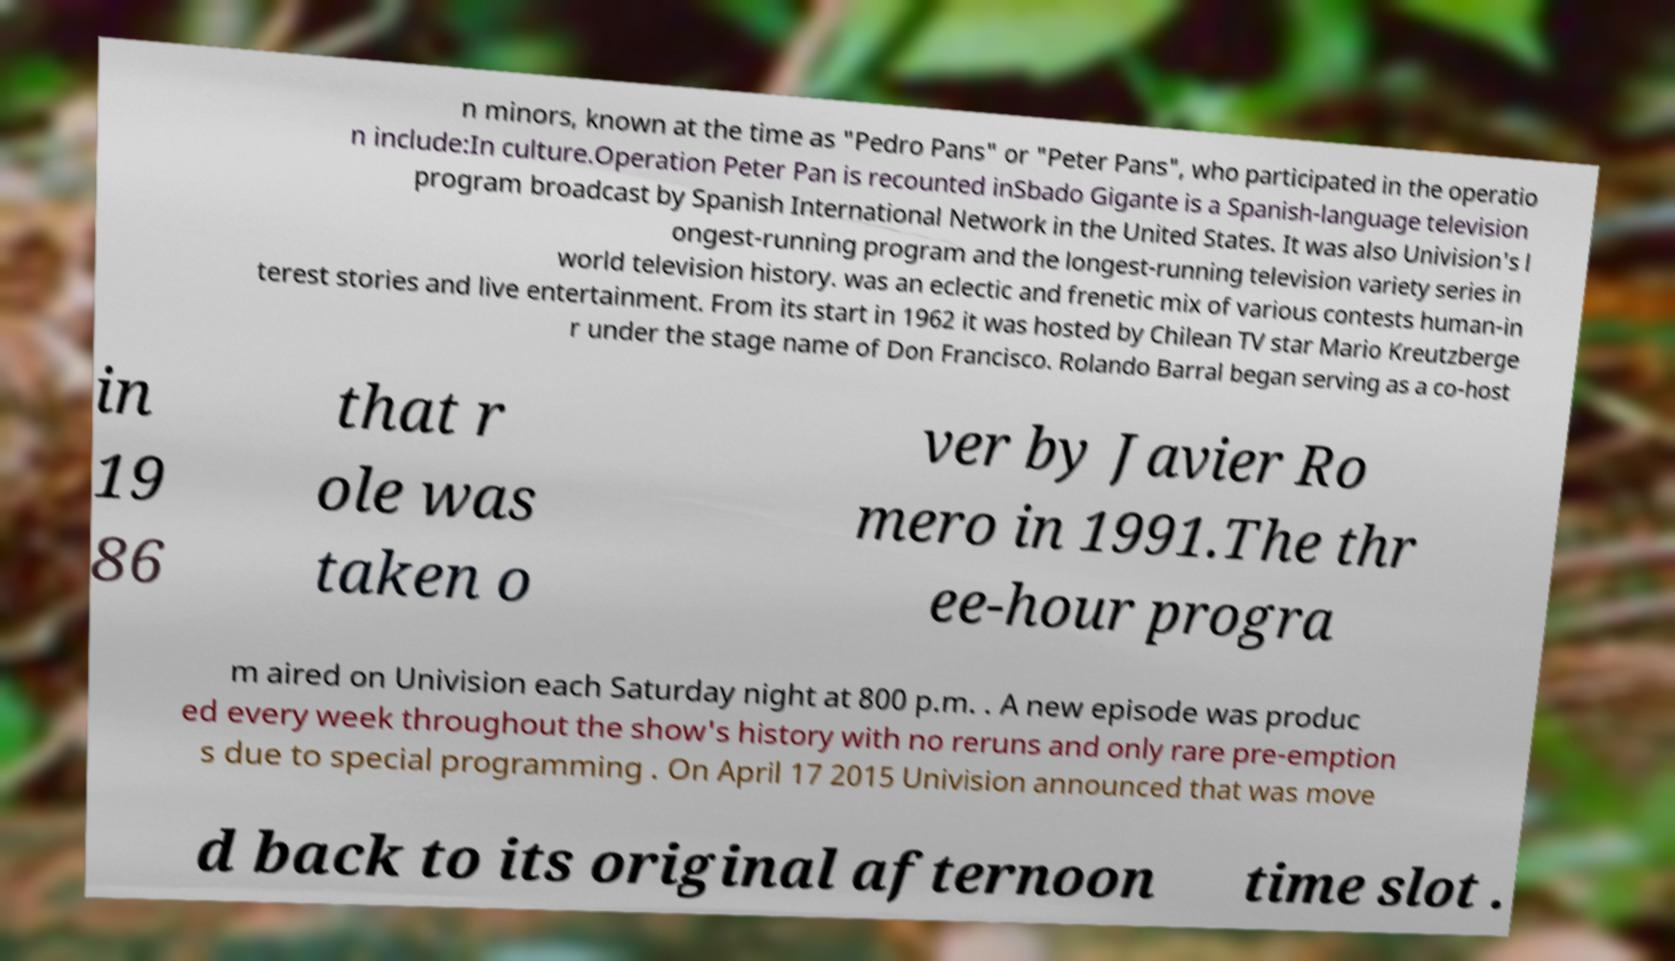There's text embedded in this image that I need extracted. Can you transcribe it verbatim? n minors, known at the time as "Pedro Pans" or "Peter Pans", who participated in the operatio n include:In culture.Operation Peter Pan is recounted inSbado Gigante is a Spanish-language television program broadcast by Spanish International Network in the United States. It was also Univision's l ongest-running program and the longest-running television variety series in world television history. was an eclectic and frenetic mix of various contests human-in terest stories and live entertainment. From its start in 1962 it was hosted by Chilean TV star Mario Kreutzberge r under the stage name of Don Francisco. Rolando Barral began serving as a co-host in 19 86 that r ole was taken o ver by Javier Ro mero in 1991.The thr ee-hour progra m aired on Univision each Saturday night at 800 p.m. . A new episode was produc ed every week throughout the show's history with no reruns and only rare pre-emption s due to special programming . On April 17 2015 Univision announced that was move d back to its original afternoon time slot . 